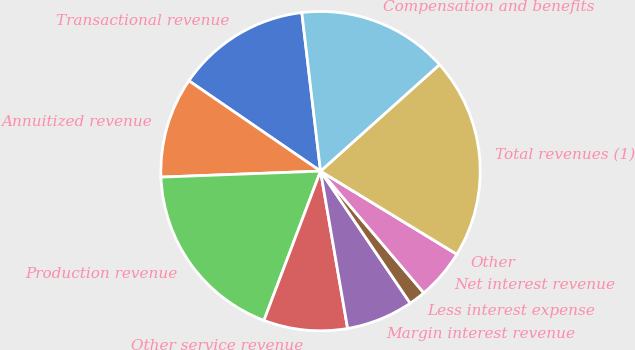<chart> <loc_0><loc_0><loc_500><loc_500><pie_chart><fcel>Transactional revenue<fcel>Annuitized revenue<fcel>Production revenue<fcel>Other service revenue<fcel>Margin interest revenue<fcel>Less interest expense<fcel>Net interest revenue<fcel>Other<fcel>Total revenues (1)<fcel>Compensation and benefits<nl><fcel>13.56%<fcel>10.17%<fcel>18.64%<fcel>8.48%<fcel>6.78%<fcel>1.7%<fcel>5.09%<fcel>0.0%<fcel>20.34%<fcel>15.25%<nl></chart> 